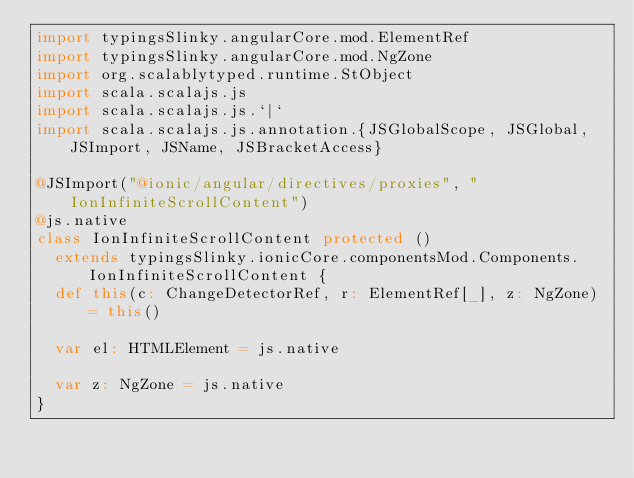<code> <loc_0><loc_0><loc_500><loc_500><_Scala_>import typingsSlinky.angularCore.mod.ElementRef
import typingsSlinky.angularCore.mod.NgZone
import org.scalablytyped.runtime.StObject
import scala.scalajs.js
import scala.scalajs.js.`|`
import scala.scalajs.js.annotation.{JSGlobalScope, JSGlobal, JSImport, JSName, JSBracketAccess}

@JSImport("@ionic/angular/directives/proxies", "IonInfiniteScrollContent")
@js.native
class IonInfiniteScrollContent protected ()
  extends typingsSlinky.ionicCore.componentsMod.Components.IonInfiniteScrollContent {
  def this(c: ChangeDetectorRef, r: ElementRef[_], z: NgZone) = this()
  
  var el: HTMLElement = js.native
  
  var z: NgZone = js.native
}
</code> 